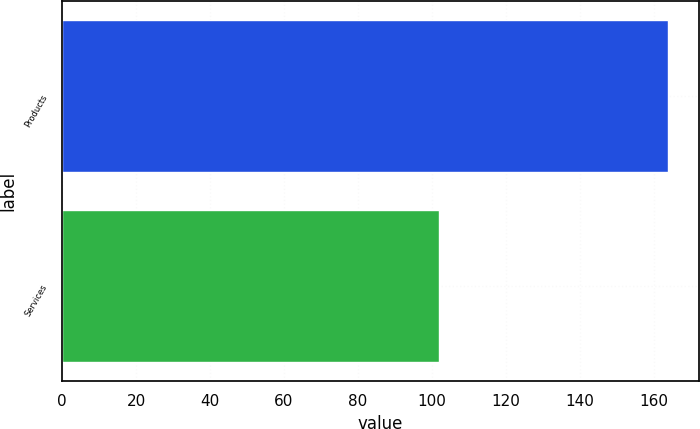Convert chart to OTSL. <chart><loc_0><loc_0><loc_500><loc_500><bar_chart><fcel>Products<fcel>Services<nl><fcel>164<fcel>102<nl></chart> 